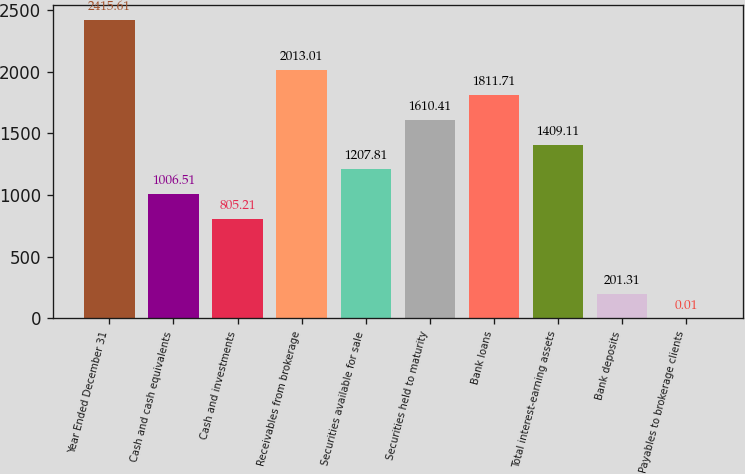<chart> <loc_0><loc_0><loc_500><loc_500><bar_chart><fcel>Year Ended December 31<fcel>Cash and cash equivalents<fcel>Cash and investments<fcel>Receivables from brokerage<fcel>Securities available for sale<fcel>Securities held to maturity<fcel>Bank loans<fcel>Total interest-earning assets<fcel>Bank deposits<fcel>Payables to brokerage clients<nl><fcel>2415.61<fcel>1006.51<fcel>805.21<fcel>2013.01<fcel>1207.81<fcel>1610.41<fcel>1811.71<fcel>1409.11<fcel>201.31<fcel>0.01<nl></chart> 